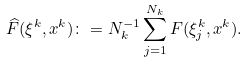Convert formula to latex. <formula><loc_0><loc_0><loc_500><loc_500>\widehat { F } ( \xi ^ { k } , x ^ { k } ) \colon = N _ { k } ^ { - 1 } \sum _ { j = 1 } ^ { N _ { k } } F ( \xi _ { j } ^ { k } , x ^ { k } ) .</formula> 